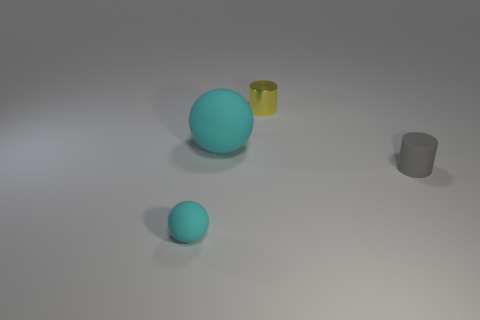There is a matte sphere on the right side of the tiny rubber thing on the left side of the shiny thing; what is its size?
Ensure brevity in your answer.  Large. The other tiny object that is the same shape as the tiny shiny object is what color?
Provide a succinct answer. Gray. What number of other gray matte objects have the same shape as the gray object?
Your answer should be compact. 0. What number of objects are either gray matte things or cylinders to the right of the yellow cylinder?
Ensure brevity in your answer.  1. There is a metallic cylinder; does it have the same color as the ball in front of the big cyan matte thing?
Your response must be concise. No. There is a object that is behind the tiny matte ball and left of the tiny yellow metal cylinder; what is its size?
Your answer should be compact. Large. Are there any gray cylinders behind the large cyan object?
Provide a short and direct response. No. There is a sphere that is in front of the large cyan matte object; are there any spheres that are to the right of it?
Ensure brevity in your answer.  Yes. Is the number of shiny objects in front of the large matte object the same as the number of small yellow metal things on the left side of the tiny cyan sphere?
Offer a terse response. Yes. There is a small cylinder that is the same material as the big sphere; what color is it?
Provide a succinct answer. Gray. 